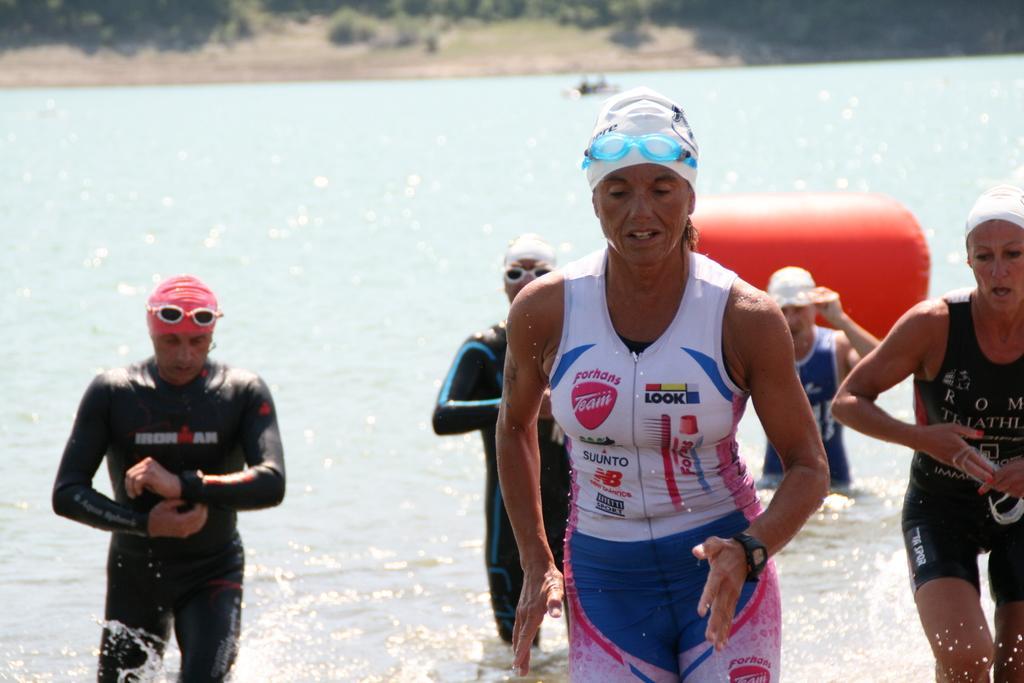Please provide a concise description of this image. In this image we can see some people in the water and in the background there are some plants and trees. 